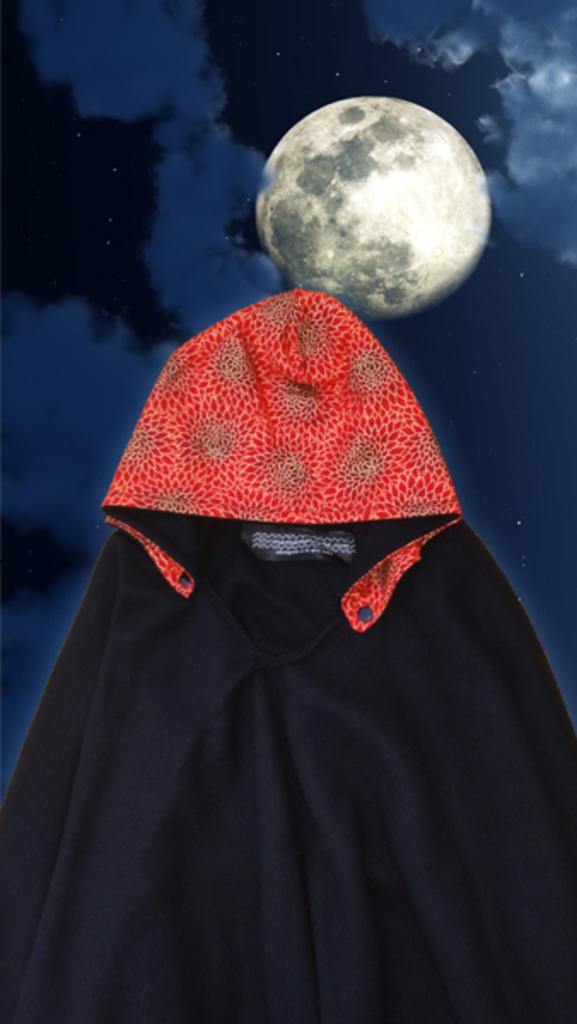What type of clothing item is in the image? There is a jacket in the image. What colors are present on the jacket? The jacket has red and black colors. What can be seen in the background of the image? The moon is visible in the background of the image. What color is the moon in the image? The moon is white in color. What colors are present in the sky in the image? The sky is black and blue in color. Reasoning: To create the conversation, we first identify the main subject of the image, which is the jacket. We then describe its colors to provide more detail. Next, we shift our focus to the background of the image, mentioning the presence of the moon. We describe the color of the moon and the colors of the sky to give a sense of the overall scene. Absurd Question/Answer: Can you see a rifle being used by a toad in the image? No, there is no rifle or toad present in the image. 